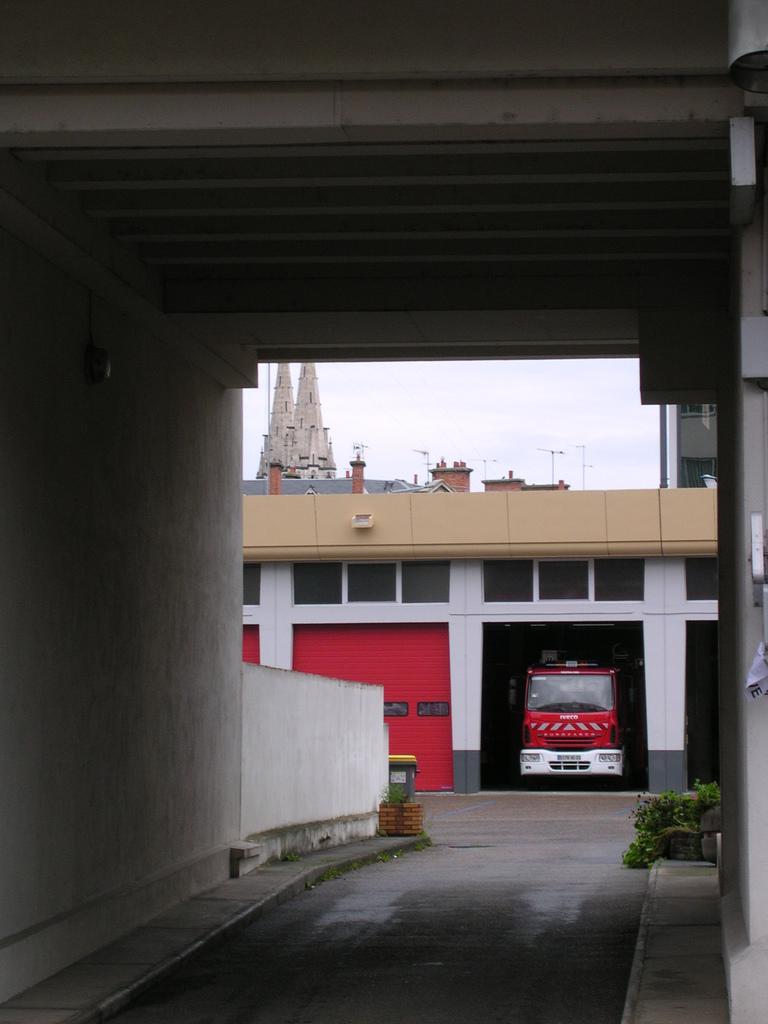How would you summarize this image in a sentence or two? In this image we can see a motor vehicle in the garage, shutter doors, building, plants, street poles and sky. 